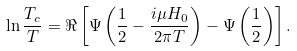Convert formula to latex. <formula><loc_0><loc_0><loc_500><loc_500>\ln \frac { T _ { c } } { T } = \Re \left [ \Psi \left ( \frac { 1 } { 2 } - \frac { i \mu H _ { 0 } } { 2 \pi T } \right ) - \Psi \left ( \frac { 1 } { 2 } \right ) \right ] .</formula> 